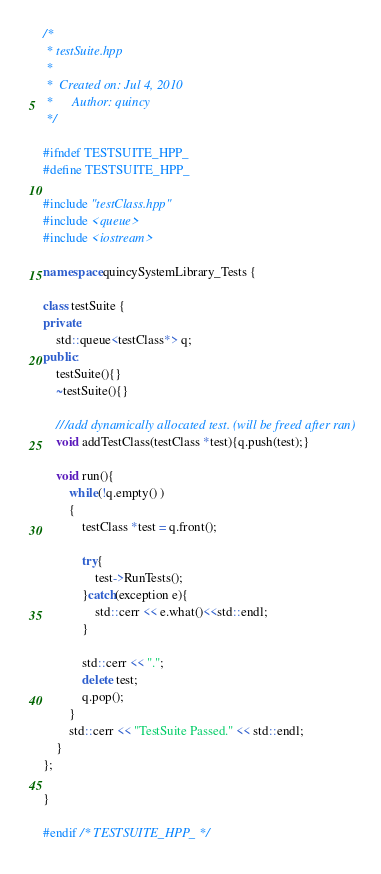Convert code to text. <code><loc_0><loc_0><loc_500><loc_500><_C++_>/*
 * testSuite.hpp
 *
 *  Created on: Jul 4, 2010
 *      Author: quincy
 */

#ifndef TESTSUITE_HPP_
#define TESTSUITE_HPP_

#include "testClass.hpp"
#include <queue>
#include <iostream>

namespace quincySystemLibrary_Tests {

class testSuite {
private:
	std::queue<testClass*> q;
public:
	testSuite(){}
	~testSuite(){}

	///add dynamically allocated test. (will be freed after ran)
	void addTestClass(testClass *test){q.push(test);}

	void run(){
		while(!q.empty() )
		{
			testClass *test = q.front();

			try{
				test->RunTests();
			}catch(exception e){
				std::cerr << e.what()<<std::endl;
			}

			std::cerr << ".";
			delete test;
			q.pop();
		}
		std::cerr << "TestSuite Passed." << std::endl;
	}
};

}

#endif /* TESTSUITE_HPP_ */
</code> 